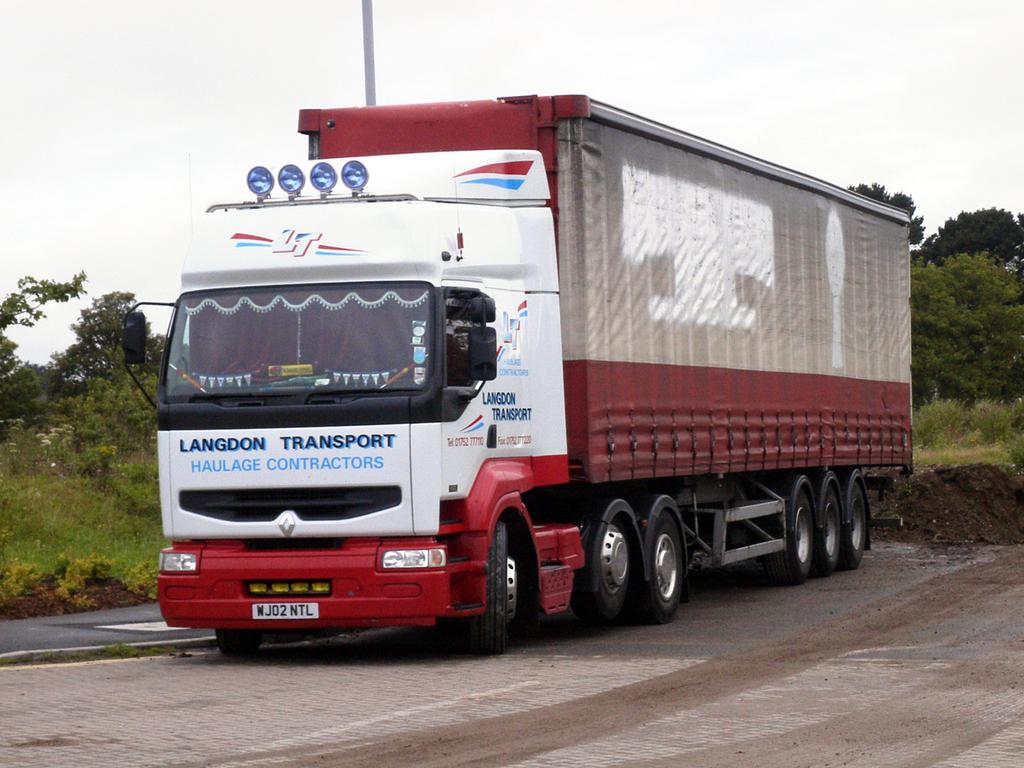What is the main subject of the image? The main subject of the image is a lorry. Where is the lorry located in the image? The lorry is on the road in the image. What is the color scheme of the lorry? The lorry has a white and red color scheme. What can be seen in the background of the image? There are trees and the sky visible in the background of the image. Can you tell me how much honey is being transported by the lorry in the image? There is no indication of honey or any other cargo being transported by the lorry in the image. Is there a robin perched on the lorry in the image? There is no robin or any other bird visible in the image. 